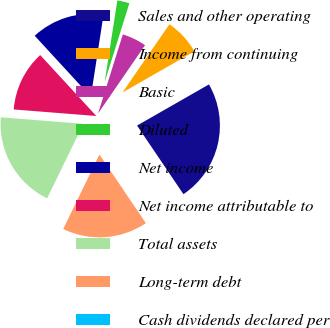<chart> <loc_0><loc_0><loc_500><loc_500><pie_chart><fcel>Sales and other operating<fcel>Income from continuing<fcel>Basic<fcel>Diluted<fcel>Net income<fcel>Net income attributable to<fcel>Total assets<fcel>Long-term debt<fcel>Cash dividends declared per<nl><fcel>23.81%<fcel>7.14%<fcel>4.76%<fcel>2.38%<fcel>14.29%<fcel>11.9%<fcel>19.05%<fcel>16.67%<fcel>0.0%<nl></chart> 